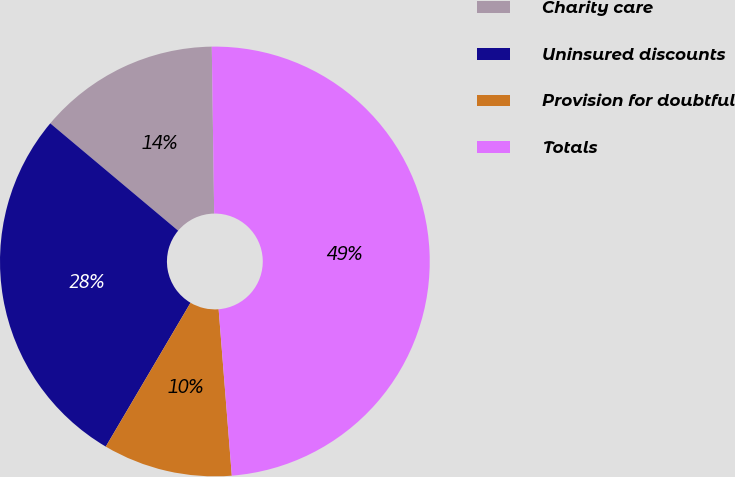Convert chart. <chart><loc_0><loc_0><loc_500><loc_500><pie_chart><fcel>Charity care<fcel>Uninsured discounts<fcel>Provision for doubtful<fcel>Totals<nl><fcel>13.66%<fcel>27.64%<fcel>9.73%<fcel>48.97%<nl></chart> 